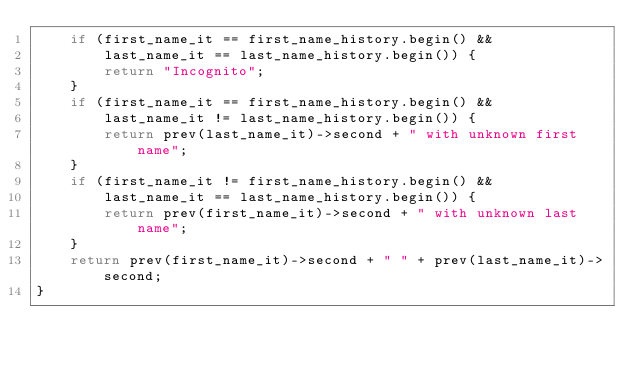Convert code to text. <code><loc_0><loc_0><loc_500><loc_500><_C++_>    if (first_name_it == first_name_history.begin() &&
        last_name_it == last_name_history.begin()) {
        return "Incognito";
    }
    if (first_name_it == first_name_history.begin() &&
        last_name_it != last_name_history.begin()) {
        return prev(last_name_it)->second + " with unknown first name";
    }
    if (first_name_it != first_name_history.begin() &&
        last_name_it == last_name_history.begin()) {
        return prev(first_name_it)->second + " with unknown last name";
    }
    return prev(first_name_it)->second + " " + prev(last_name_it)->second;
}
</code> 